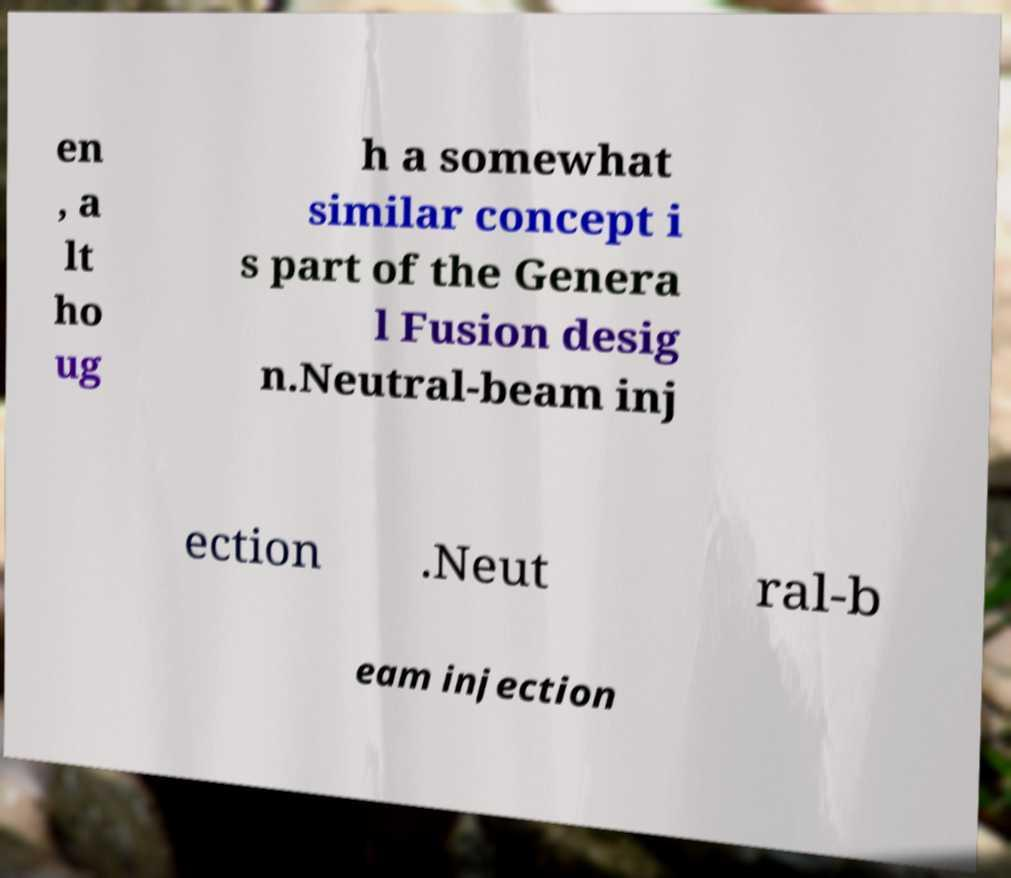There's text embedded in this image that I need extracted. Can you transcribe it verbatim? en , a lt ho ug h a somewhat similar concept i s part of the Genera l Fusion desig n.Neutral-beam inj ection .Neut ral-b eam injection 